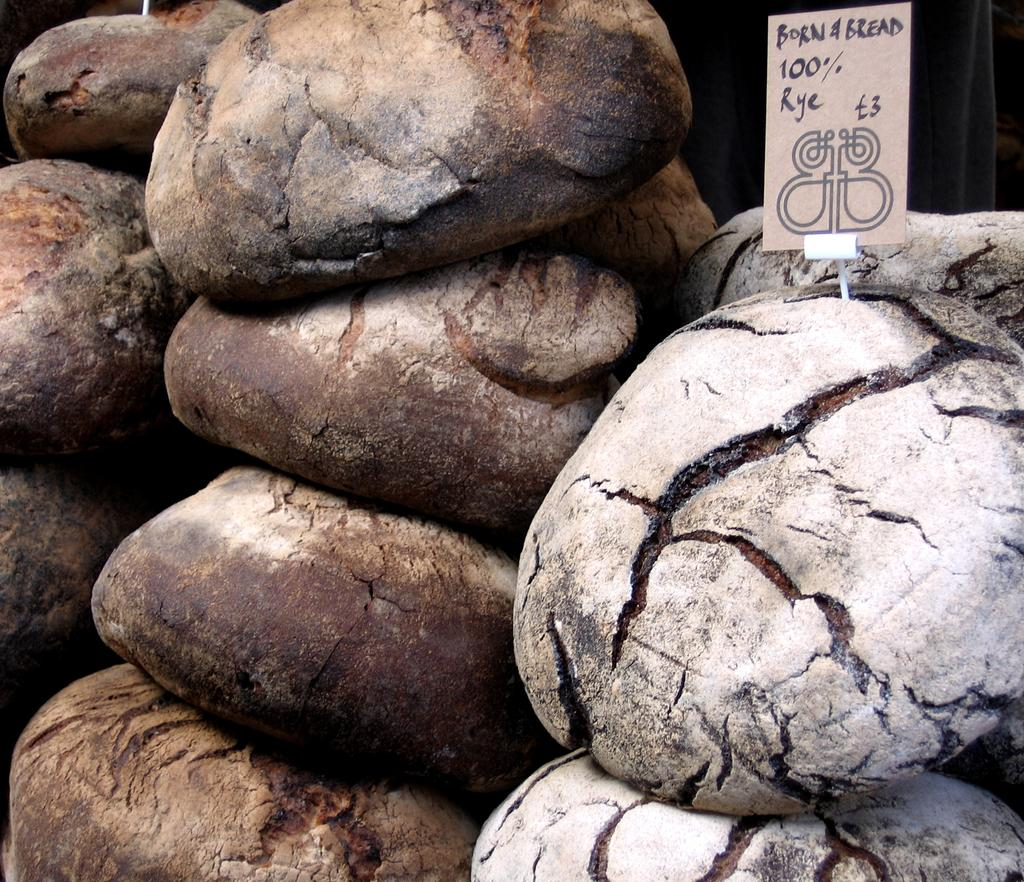What type of items can be seen in the image? There is food and a card in the image. Can you describe the food in the image? Unfortunately, the specific type of food cannot be determined from the provided facts. What is the purpose of the card in the image? The purpose of the card in the image cannot be determined from the provided facts. What type of plants can be seen growing on the linen in the image? There is no mention of plants or linen in the provided facts, so this question cannot be answered definitively. 